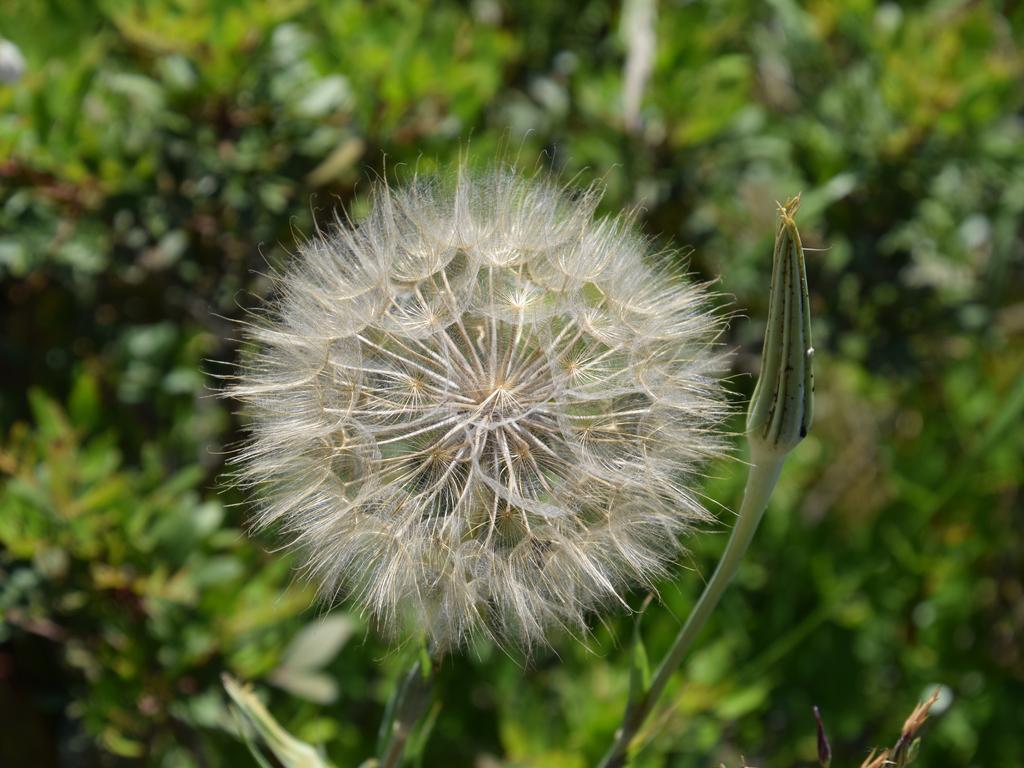How would you summarize this image in a sentence or two? In the center of the image we can see a flower and a bud. In the background there are trees. 